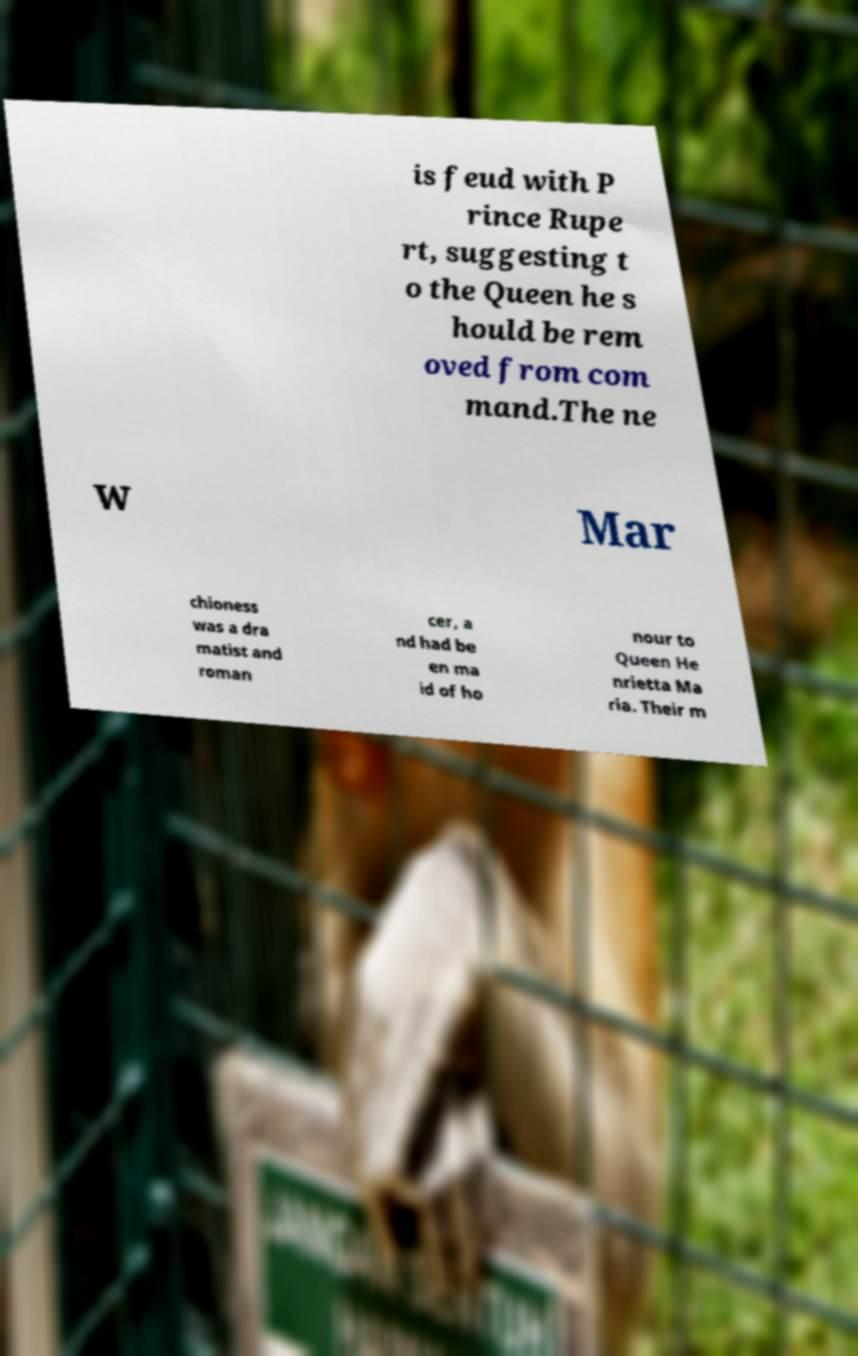Could you extract and type out the text from this image? is feud with P rince Rupe rt, suggesting t o the Queen he s hould be rem oved from com mand.The ne w Mar chioness was a dra matist and roman cer, a nd had be en ma id of ho nour to Queen He nrietta Ma ria. Their m 